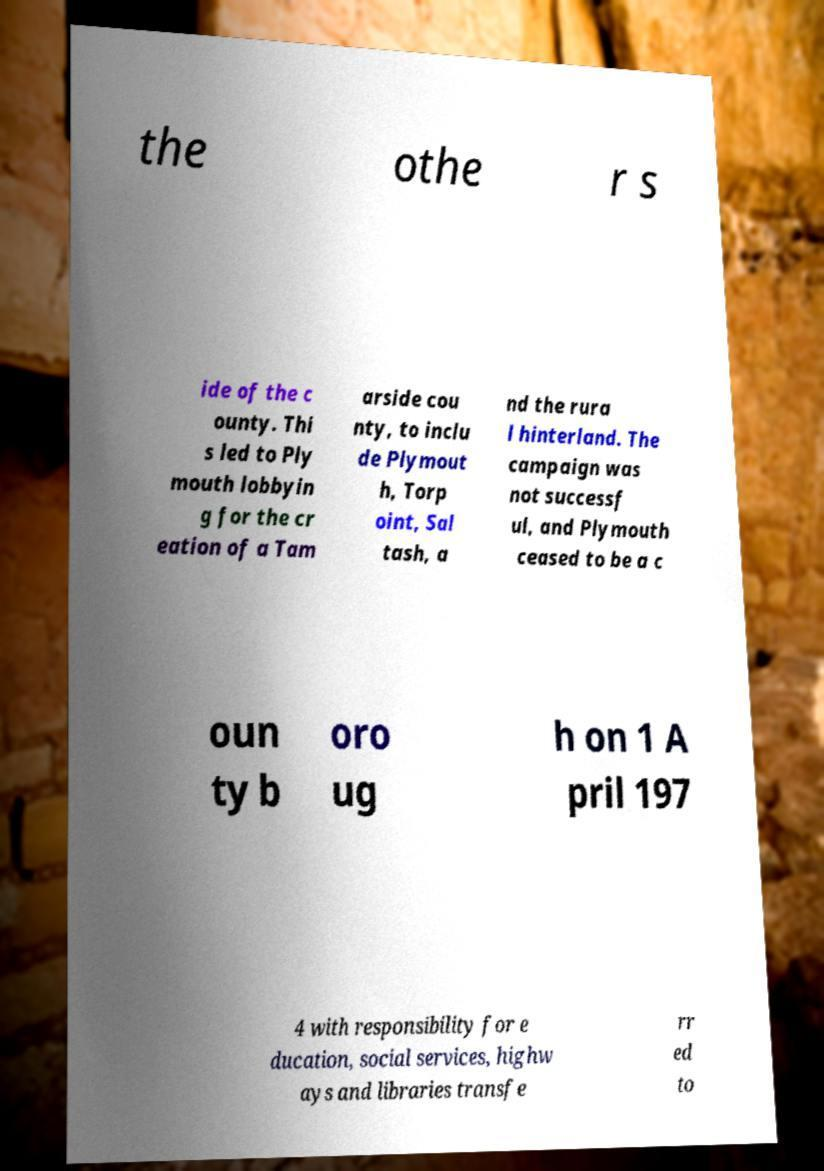Could you extract and type out the text from this image? the othe r s ide of the c ounty. Thi s led to Ply mouth lobbyin g for the cr eation of a Tam arside cou nty, to inclu de Plymout h, Torp oint, Sal tash, a nd the rura l hinterland. The campaign was not successf ul, and Plymouth ceased to be a c oun ty b oro ug h on 1 A pril 197 4 with responsibility for e ducation, social services, highw ays and libraries transfe rr ed to 